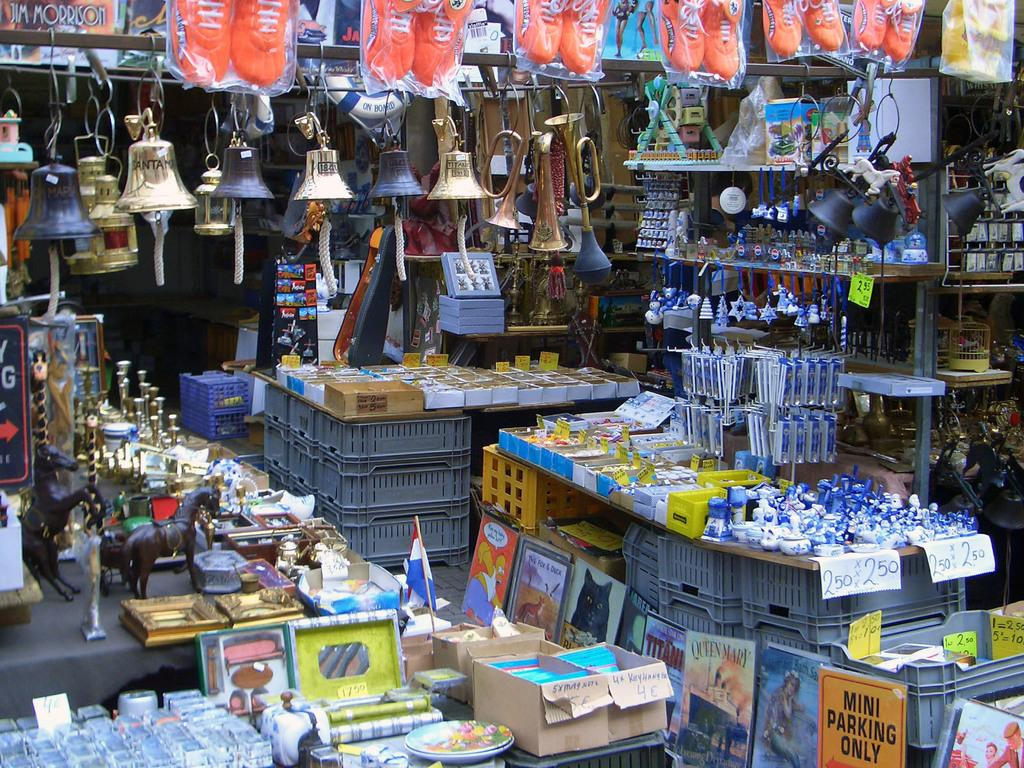<image>
Present a compact description of the photo's key features. a store of many different things including a sign that says 'mini parking only' 